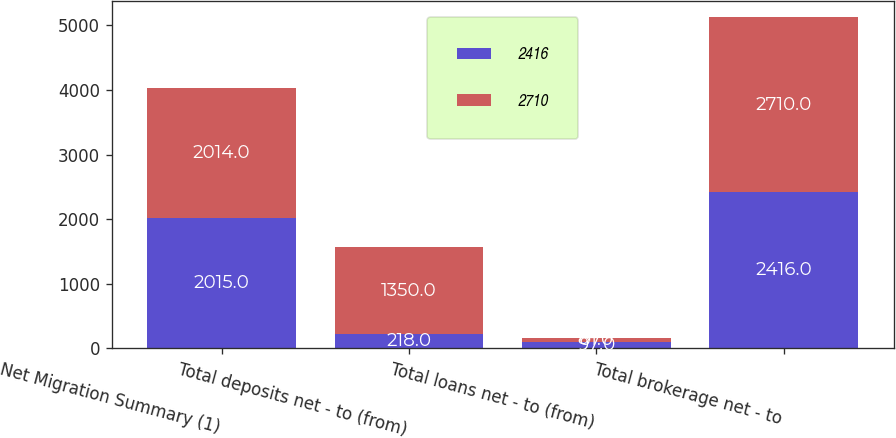Convert chart to OTSL. <chart><loc_0><loc_0><loc_500><loc_500><stacked_bar_chart><ecel><fcel>Net Migration Summary (1)<fcel>Total deposits net - to (from)<fcel>Total loans net - to (from)<fcel>Total brokerage net - to<nl><fcel>2416<fcel>2015<fcel>218<fcel>97<fcel>2416<nl><fcel>2710<fcel>2014<fcel>1350<fcel>61<fcel>2710<nl></chart> 